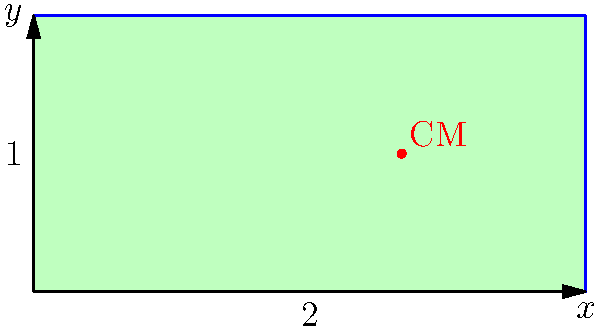A rectangular plate has a length of 2 units and a height of 1 unit. The density of the plate varies linearly with x, given by the function $\rho(x) = 2x + 1$. Calculate the x-coordinate of the center of mass for this non-uniform density plate. To find the center of mass of a non-uniform density object, we need to use the following steps:

1) The formula for the x-coordinate of the center of mass is:

   $$x_{CM} = \frac{\int\int x \rho(x,y) dA}{\int\int \rho(x,y) dA}$$

2) In this case, $\rho(x,y) = \rho(x) = 2x + 1$, and $dA = dy dx$

3) The limits of integration are:
   $x: 0$ to $2$
   $y: 0$ to $1$

4) Let's calculate the numerator first:

   $$\int_0^2 \int_0^1 x(2x+1) dy dx = \int_0^2 x(2x+1) dx = \left[\frac{2x^3}{3} + \frac{x^2}{2}\right]_0^2 = \frac{16}{3} + 2 = \frac{22}{3}$$

5) Now the denominator:

   $$\int_0^2 \int_0^1 (2x+1) dy dx = \int_0^2 (2x+1) dx = \left[x^2 + x\right]_0^2 = 4 + 2 = 6$$

6) Dividing the numerator by the denominator:

   $$x_{CM} = \frac{22/3}{6} = \frac{11}{9} \approx 1.22$$

Therefore, the x-coordinate of the center of mass is $\frac{11}{9}$ units from the left edge of the plate.
Answer: $\frac{11}{9}$ units 